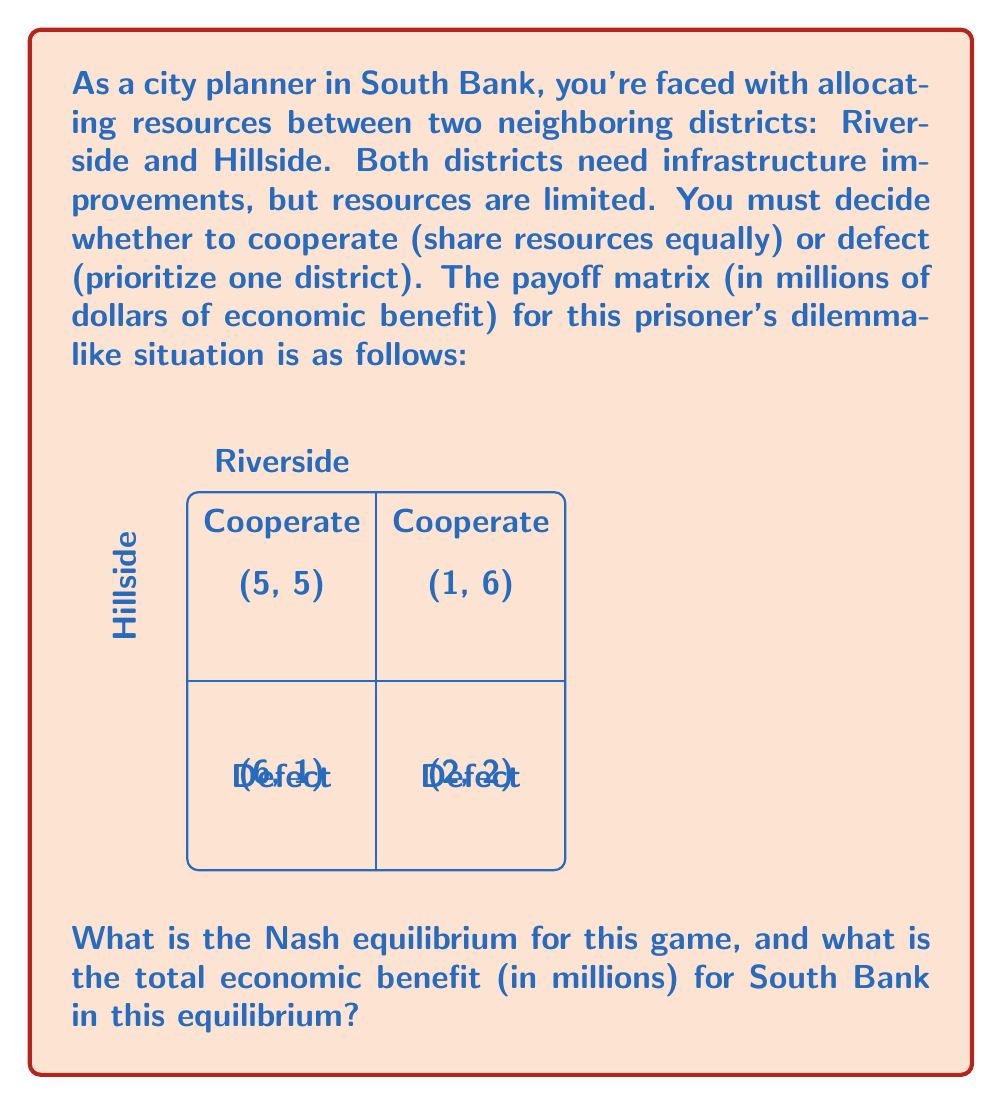Could you help me with this problem? To solve this prisoner's dilemma-like problem, we need to follow these steps:

1) Identify the dominant strategy for each player (district):

   For Riverside:
   - If Hillside cooperates: Defect (6) > Cooperate (5)
   - If Hillside defects: Defect (2) > Cooperate (1)
   
   For Hillside:
   - If Riverside cooperates: Defect (6) > Cooperate (5)
   - If Riverside defects: Defect (2) > Cooperate (1)

2) The dominant strategy for both districts is to defect, regardless of what the other district does.

3) The Nash equilibrium occurs when both districts play their dominant strategy. In this case, it's (Defect, Defect).

4) In the (Defect, Defect) scenario, each district receives an economic benefit of 2 million dollars.

5) The total economic benefit for South Bank is the sum of benefits for both districts:

   $$2 + 2 = 4$$ million dollars

Therefore, the Nash equilibrium is (Defect, Defect), and the total economic benefit for South Bank in this equilibrium is 4 million dollars.
Answer: Nash equilibrium: (Defect, Defect); Total economic benefit: $4 million 